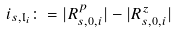Convert formula to latex. <formula><loc_0><loc_0><loc_500><loc_500>i _ { s , \mathfrak { l } _ { i } } \colon = | R _ { s , 0 , i } ^ { p } | - | R _ { s , 0 , i } ^ { z } |</formula> 